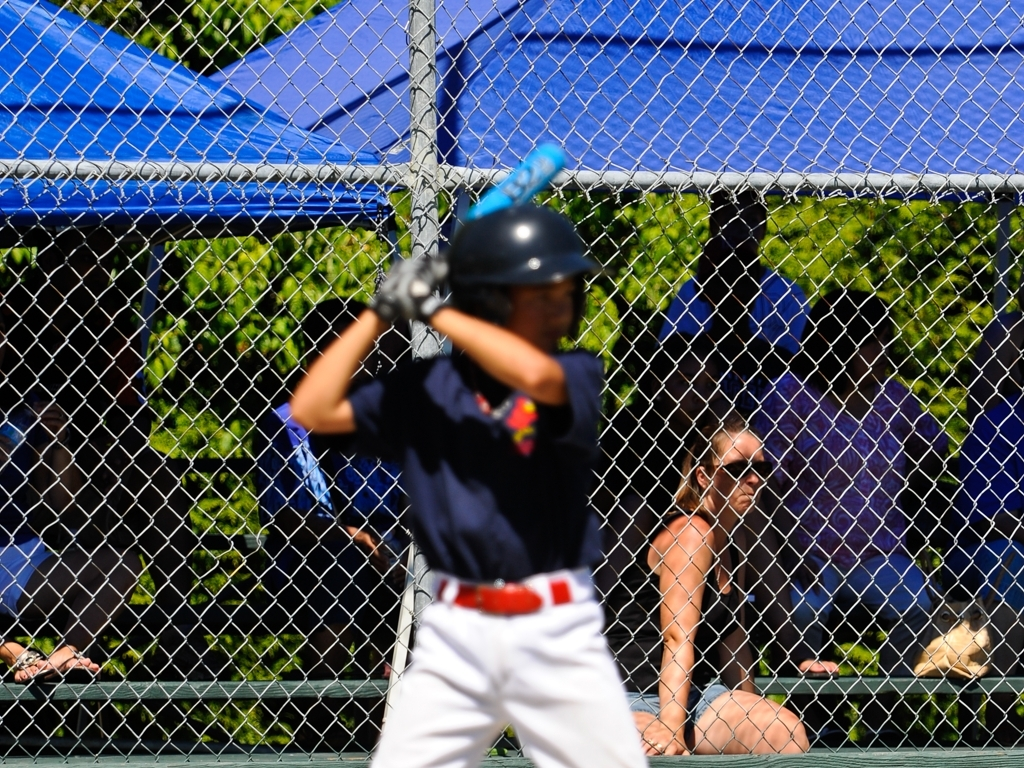Can you describe the setting and potential event taking place? The setting appears to be an outdoor baseball field on a bright sunny day. The image captures a moment during a baseball game, as suggested by the individual wearing a batting helmet and holding a bat. The fencing in the foreground suggests that we are viewing the scene from behind home plate or the dugout area, common spectator viewpoints during a game. Is there anything noteworthy about the equipment or uniform? The player's equipment is standard for baseball, including the batting helmet which is essential for safety, and a jersey that represents their team. Details on the uniform, such as logos or numbers, are difficult to discern due to the blur. However, the presence of a batting helmet and jersey does confirm an organized baseball event, likely competitive in nature. 